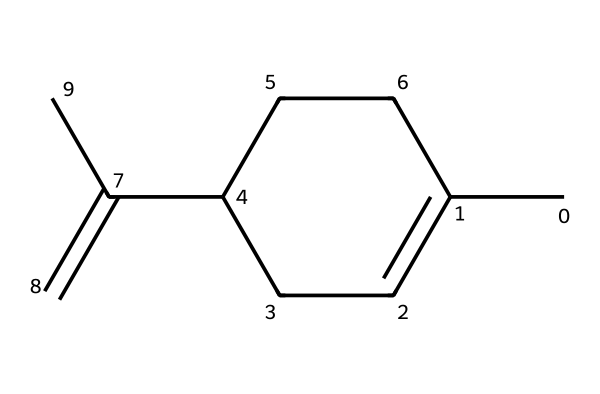What is the molecular formula of limonene? To determine the molecular formula, we count the number of carbon (C) and hydrogen (H) atoms in the SMILES representation. There are 10 carbon atoms and 16 hydrogen atoms, which gives us the molecular formula C10H16.
Answer: C10H16 How many rings are present in the structure? By examining the structure, we see that there is one cyclical part (the cyclohexene portion). Thus, there is one ring.
Answer: 1 What is the degree of unsaturation of this compound? The degree of unsaturation can be calculated using the formula: Degree of Unsaturation = (2C + 2 - H)/2. Plugging in 10 carbon atoms and 16 hydrogen atoms gives us (2*10 + 2 - 16)/2 = 3. This indicates three degrees of unsaturation, attributed to the double bonds and cyclic structure.
Answer: 3 Is limonene a saturated or unsaturated hydrocarbon? Since limonene has double bonds (as indicated by the presence of multiple degrees of unsaturation), it is categorized as an unsaturated hydrocarbon.
Answer: unsaturated What type of hydrocarbon is limonene classified as? Limonene is classified as a terpene, which is a type of hydrocarbon derived from the isoprene units, characteristic for having multiple double bonds and cyclic structures.
Answer: terpene How many hydrogen atoms are attached to each of the double-bonded carbons? In the SMILES representation and considering its structure, each of the carbon atoms involved in the double bonds typically has one hydrogen atom attached to it.
Answer: 1 